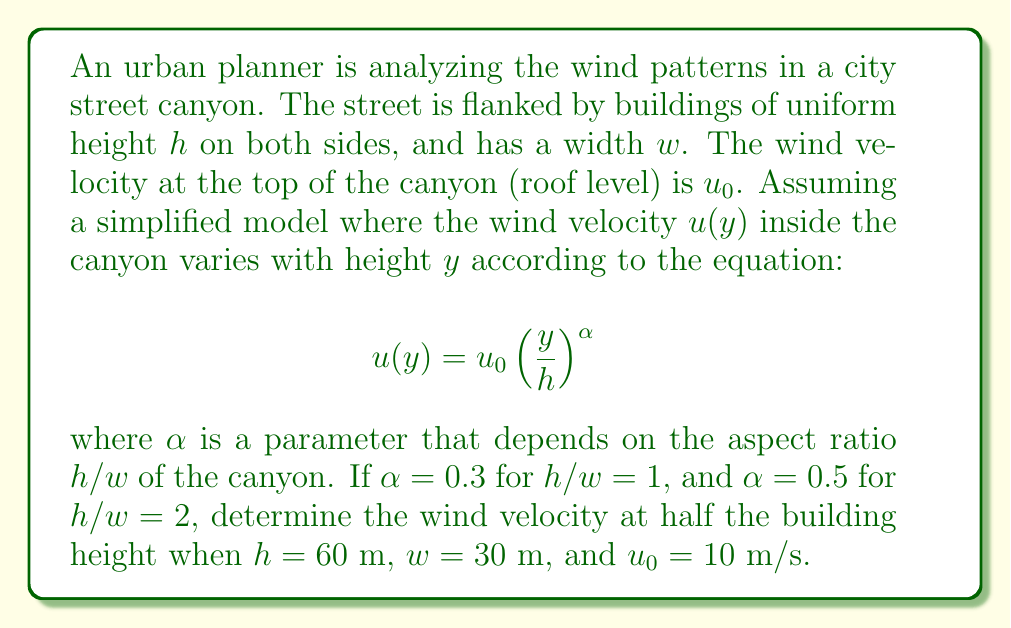Solve this math problem. To solve this problem, we need to follow these steps:

1. Calculate the aspect ratio $h/w$ of the canyon:
   $$ \frac{h}{w} = \frac{60 \text{ m}}{30 \text{ m}} = 2 $$

2. Determine the appropriate $\alpha$ value:
   Since $h/w = 2$, we use $\alpha = 0.5$

3. Calculate the wind velocity at half the building height:
   - Half the building height is $y = h/2 = 60 \text{ m} / 2 = 30 \text{ m}$
   - Substitute the values into the equation:

   $$ u(y) = u_0 \left(\frac{y}{h}\right)^{\alpha} $$
   $$ u(30) = 10 \text{ m/s} \left(\frac{30 \text{ m}}{60 \text{ m}}\right)^{0.5} $$
   $$ u(30) = 10 \text{ m/s} \left(\frac{1}{2}\right)^{0.5} $$
   $$ u(30) = 10 \text{ m/s} \cdot \frac{1}{\sqrt{2}} $$
   $$ u(30) = \frac{10}{\sqrt{2}} \text{ m/s} $$

4. Simplify the final answer:
   $$ u(30) = 10 \cdot \frac{\sqrt{2}}{2} \text{ m/s} = 5\sqrt{2} \text{ m/s} \approx 7.07 \text{ m/s} $$
Answer: The wind velocity at half the building height is $5\sqrt{2} \text{ m/s}$ or approximately $7.07 \text{ m/s}$. 